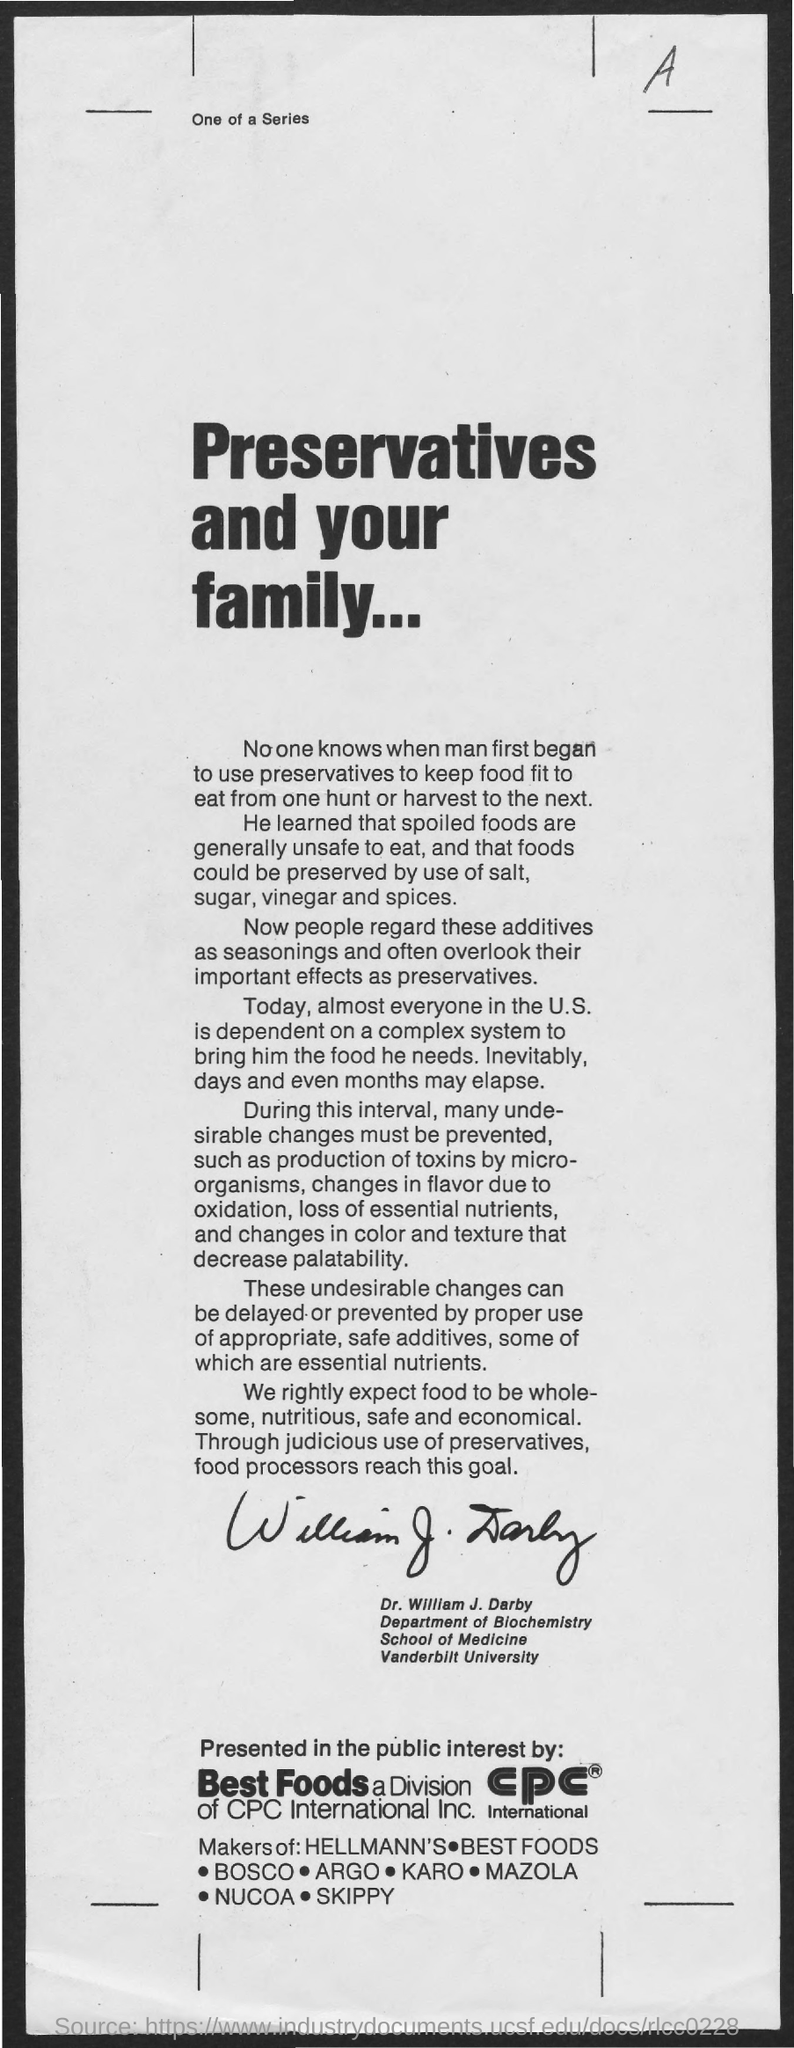Which letter is at the top-right of the document?
Provide a short and direct response. A. What is the main title of the document?
Provide a succinct answer. PRESERVATIVES AND YOUR FAMILY... William J. Darby belongs to which university?
Provide a short and direct response. Vanderbilt University. William J. Darby belongs to which department?
Make the answer very short. DEPARTMENT OF BIOCHEMISTRY. 